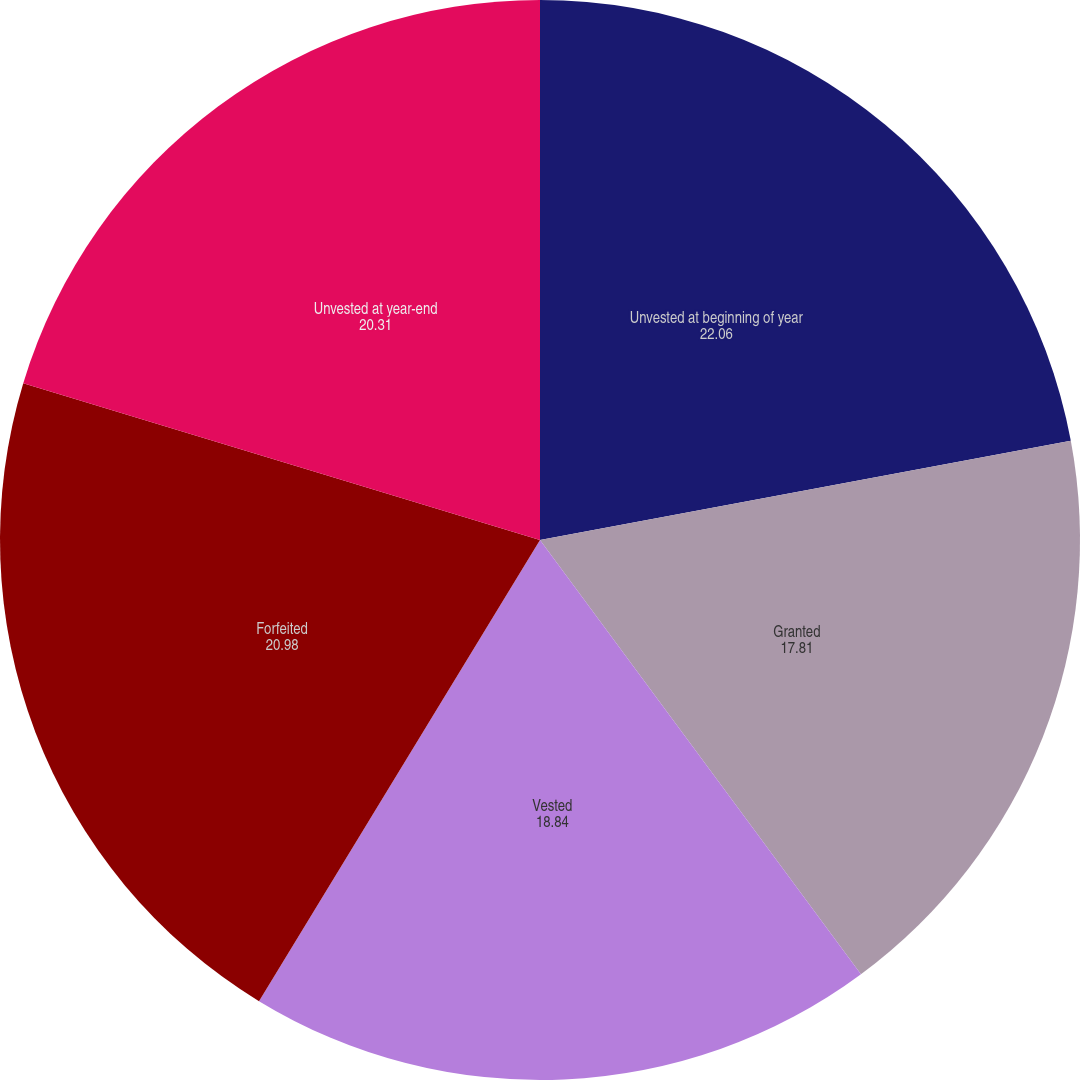Convert chart. <chart><loc_0><loc_0><loc_500><loc_500><pie_chart><fcel>Unvested at beginning of year<fcel>Granted<fcel>Vested<fcel>Forfeited<fcel>Unvested at year-end<nl><fcel>22.06%<fcel>17.81%<fcel>18.84%<fcel>20.98%<fcel>20.31%<nl></chart> 